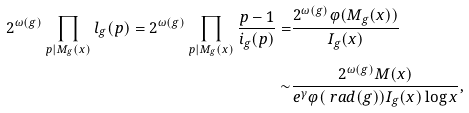Convert formula to latex. <formula><loc_0><loc_0><loc_500><loc_500>2 ^ { \omega ( g ) } \prod _ { p | M _ { g } ( x ) } l _ { g } ( p ) = 2 ^ { \omega ( g ) } \prod _ { p | M _ { g } ( x ) } \frac { p - 1 } { i _ { g } ( p ) } = & \frac { 2 ^ { \omega ( g ) } \varphi ( M _ { g } ( x ) ) } { I _ { g } ( x ) } \\ \sim & \frac { 2 ^ { \omega ( g ) } M ( x ) } { e ^ { \gamma } \varphi ( \ r a d ( g ) ) I _ { g } ( x ) \log x } ,</formula> 